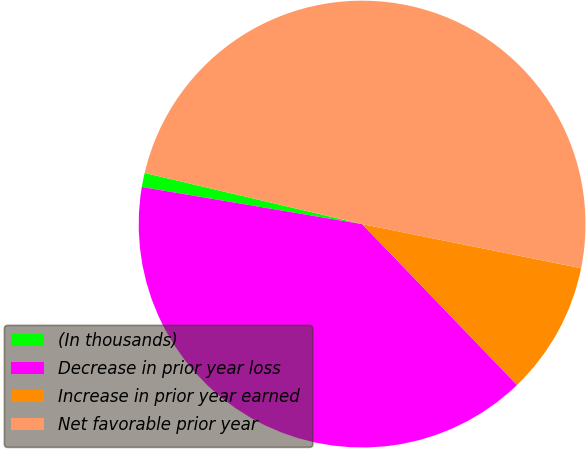Convert chart to OTSL. <chart><loc_0><loc_0><loc_500><loc_500><pie_chart><fcel>(In thousands)<fcel>Decrease in prior year loss<fcel>Increase in prior year earned<fcel>Net favorable prior year<nl><fcel>1.02%<fcel>39.86%<fcel>9.63%<fcel>49.49%<nl></chart> 